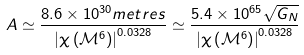<formula> <loc_0><loc_0><loc_500><loc_500>A \simeq \frac { 8 . 6 \times 1 0 ^ { 3 0 } m e t r e s } { \left | \chi \left ( \mathcal { M } ^ { 6 } \right ) \right | ^ { 0 . 0 3 2 8 } } \simeq \frac { 5 . 4 \times 1 0 ^ { 6 5 } \sqrt { G _ { N } } } { \left | \chi \left ( \mathcal { M } ^ { 6 } \right ) \right | ^ { 0 . 0 3 2 8 } }</formula> 